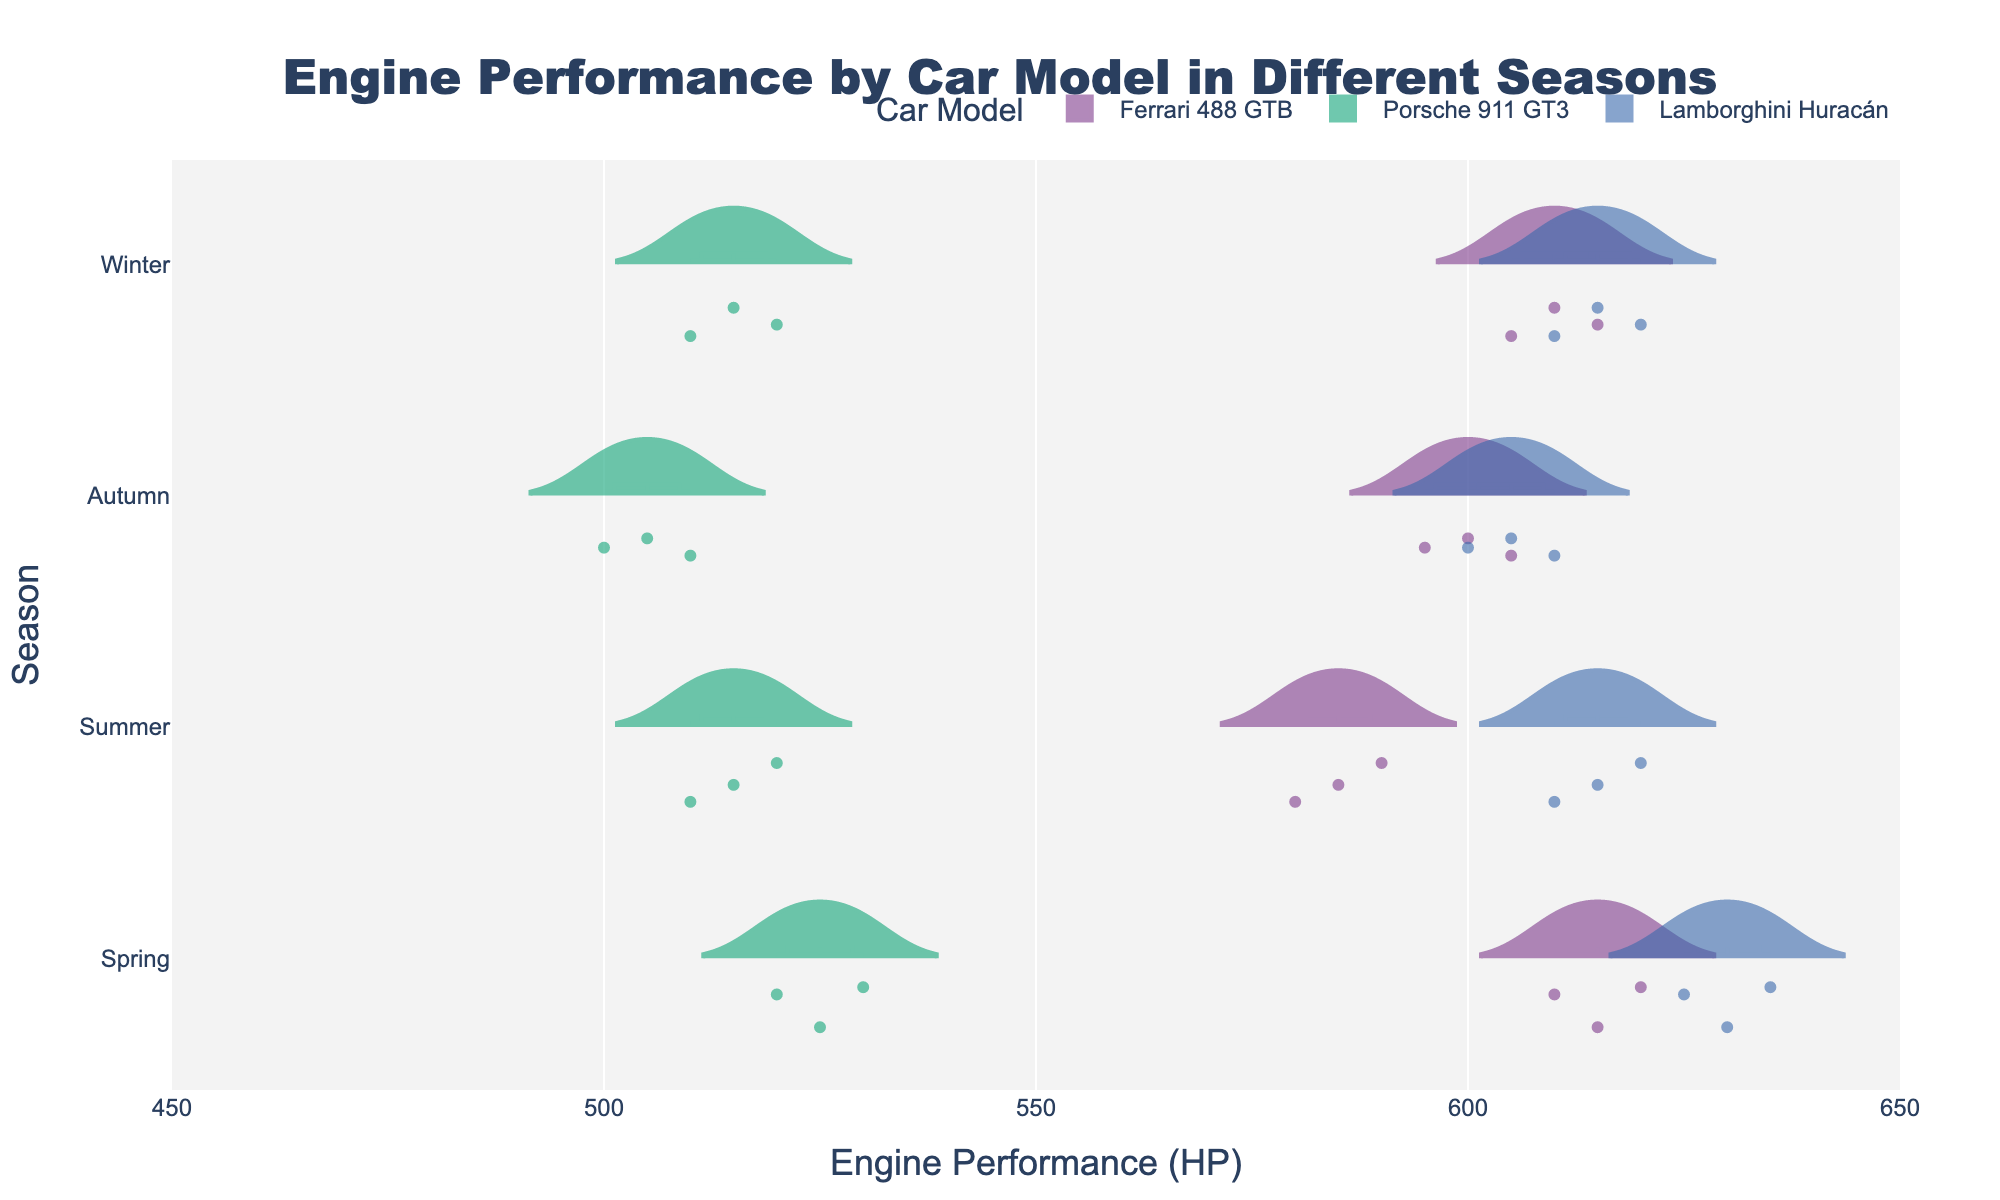What's the title of the chart? The chart title is displayed at the top and reads "Engine Performance by Car Model in Different Seasons."
Answer: Engine Performance by Car Model in Different Seasons Which car model has the highest engine performance in the Spring? By looking at the data points and the spread of engine performance values in the Spring, the Lamborghini Huracán shows the highest performance values.
Answer: Lamborghini Huracán In which season does the Ferrari 488 GTB have the lowest average engine performance? By observing the position of the mean lines in the violin plots for each season, the Ferrari 488 GTB shows lower values in the Summer compared to other seasons.
Answer: Summer What is the highest engine performance value recorded for the Porsche 911 GT3 across all seasons? Looking at the maximum points across all seasons for the Porsche 911 GT3, the highest value recorded is 530 HP.
Answer: 530 HP Which season shows the most consistent engine performance for the Lamborghini Huracán? Consistency can be observed by the width of the violin plot. A narrower plot indicates more consistent performance. The Lamborghini Huracán's Spring violin plot is narrowest, indicating most consistency.
Answer: Spring Compare the average engine performances of Ferrari 488 GTB and Porsche 911 GT3 in Winter. Which is higher? By comparing the mean lines in the Winter season for both models, the Ferrari 488 GTB has a higher average performance than the Porsche 911 GT3.
Answer: Ferrari 488 GTB Which car model has the greatest variation in engine performance during the Autumn? The width and spread of data points within the violin plot indicate variation. The Ferrari 488 GTB has the largest spread and width, indicating the greatest variation in engine performance during Autumn.
Answer: Ferrari 488 GTB How does the engine performance of the Lamborghini Huracán compare between Winter and Summer? Observing the mean lines and spread, the Lamborghini Huracán has a slightly higher average performance in Winter compared to Summer.
Answer: Higher in Winter What is the median engine performance of the Ferrari 488 GTB in Spring? The median line within the violin plot for Ferrari 488 GTB in Spring corresponds to the central value, which is around 615 HP.
Answer: 615 HP Is there any season where the engine performance of the Porsche 911 GT3 is consistently over 500 HP? Reviewing the violin plots for Porsche 911 GT3, every season has engine performance values over 500 HP, but the Summer has some points below 500. Hence, no season is consistently over 500 HP.
Answer: No 